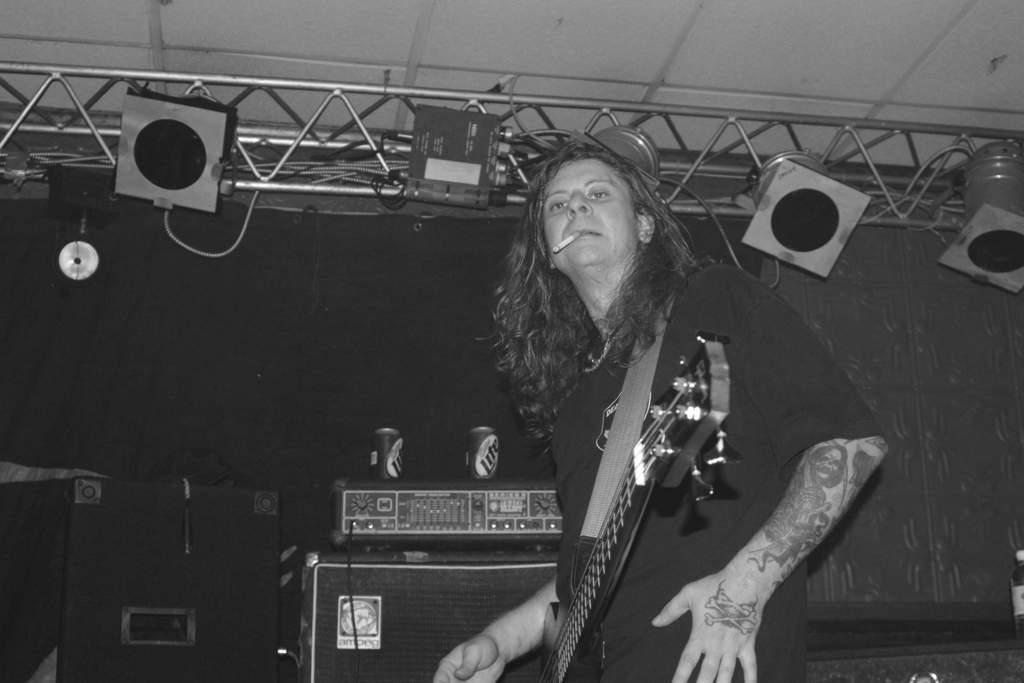What is the main subject of the image? There is a person in the image. What is the person doing in the image? The person is standing and holding a guitar. What object is in the person's mouth? There is a cigar in the person's mouth. What can be seen behind the person in the image? There are speakers visible behind the person. What type of door can be seen in the image? There is no door present in the image. How many bubbles are floating around the person in the image? There are no bubbles present in the image. 